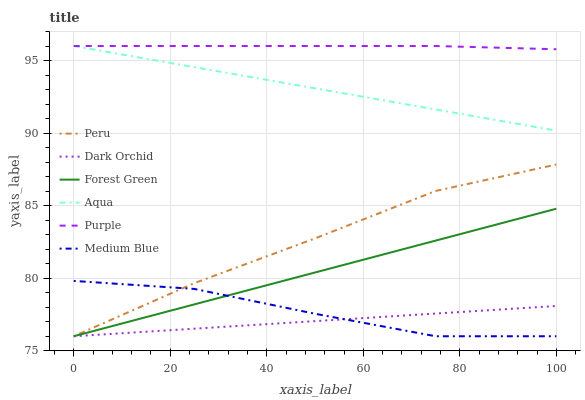Does Dark Orchid have the minimum area under the curve?
Answer yes or no. Yes. Does Purple have the maximum area under the curve?
Answer yes or no. Yes. Does Aqua have the minimum area under the curve?
Answer yes or no. No. Does Aqua have the maximum area under the curve?
Answer yes or no. No. Is Forest Green the smoothest?
Answer yes or no. Yes. Is Medium Blue the roughest?
Answer yes or no. Yes. Is Aqua the smoothest?
Answer yes or no. No. Is Aqua the roughest?
Answer yes or no. No. Does Medium Blue have the lowest value?
Answer yes or no. Yes. Does Aqua have the lowest value?
Answer yes or no. No. Does Aqua have the highest value?
Answer yes or no. Yes. Does Medium Blue have the highest value?
Answer yes or no. No. Is Dark Orchid less than Aqua?
Answer yes or no. Yes. Is Purple greater than Dark Orchid?
Answer yes or no. Yes. Does Dark Orchid intersect Medium Blue?
Answer yes or no. Yes. Is Dark Orchid less than Medium Blue?
Answer yes or no. No. Is Dark Orchid greater than Medium Blue?
Answer yes or no. No. Does Dark Orchid intersect Aqua?
Answer yes or no. No. 